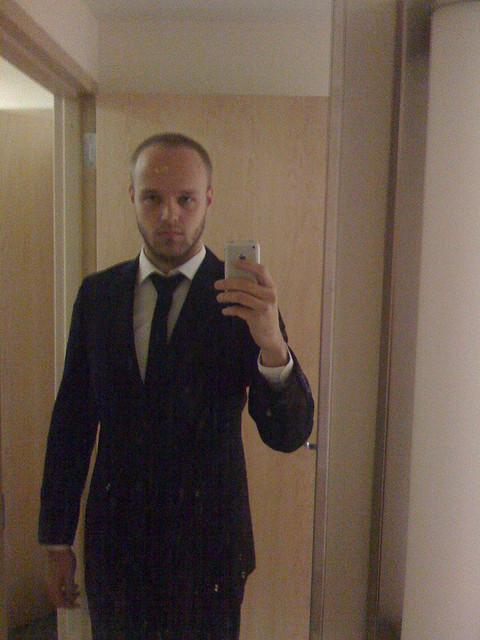Could this man be going to a funeral?
Quick response, please. Yes. Is this picture recent?
Write a very short answer. Yes. Is this man wearing jeans?
Be succinct. No. Is the man happy?
Be succinct. No. What is he wearing around his neck?
Give a very brief answer. Tie. Does the guy have good eyesight?
Give a very brief answer. Yes. 